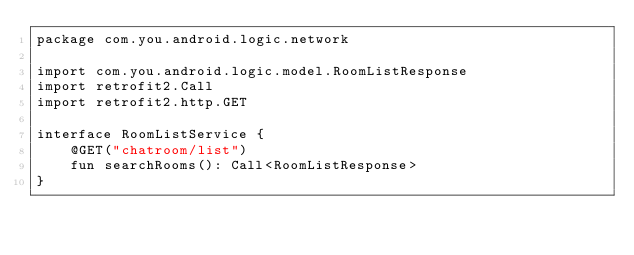<code> <loc_0><loc_0><loc_500><loc_500><_Kotlin_>package com.you.android.logic.network

import com.you.android.logic.model.RoomListResponse
import retrofit2.Call
import retrofit2.http.GET

interface RoomListService {
    @GET("chatroom/list")
    fun searchRooms(): Call<RoomListResponse>
}</code> 